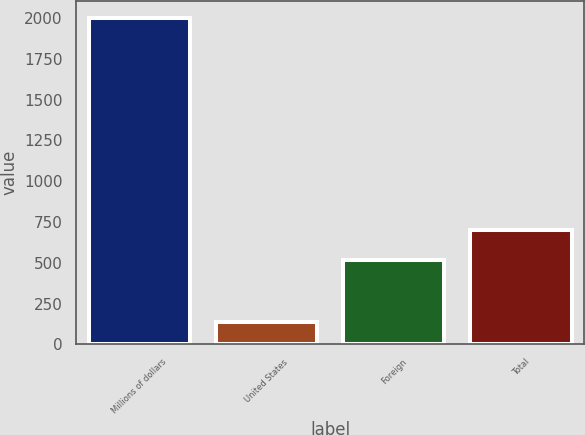Convert chart. <chart><loc_0><loc_0><loc_500><loc_500><bar_chart><fcel>Millions of dollars<fcel>United States<fcel>Foreign<fcel>Total<nl><fcel>2004<fcel>135<fcel>516<fcel>702.9<nl></chart> 